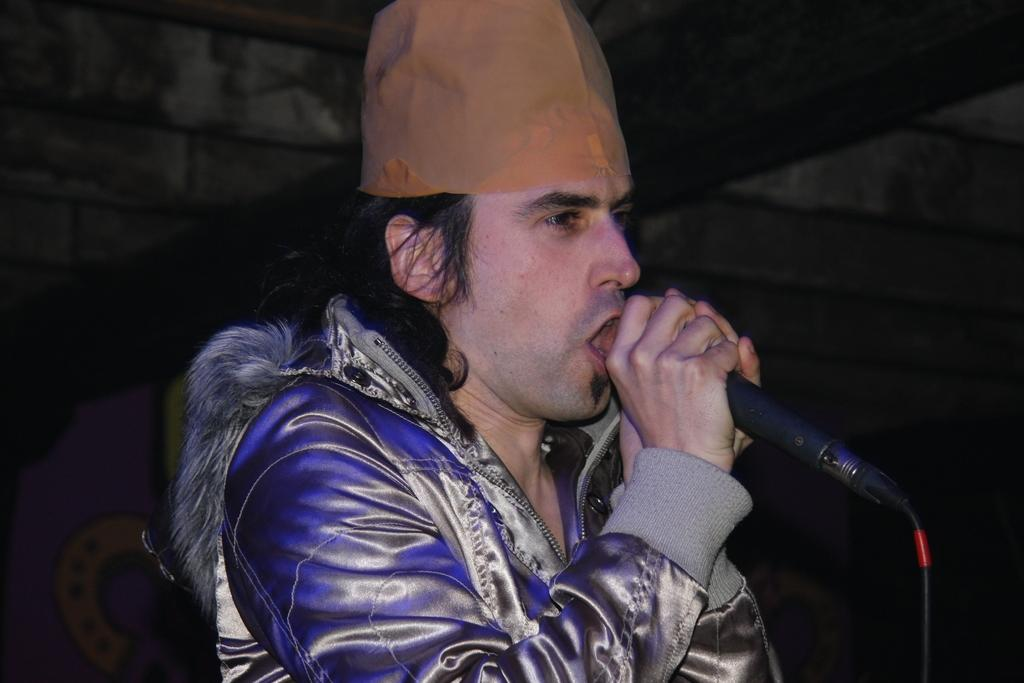What is the main subject of the image? There is a man in the image. What is the man doing in the image? The man is singing in the image. What object is the man holding while singing? The man is holding a microphone in the image. What type of clothing is the man wearing on his upper body? The man is wearing a coat in the image. What type of headwear is the man wearing? The man is wearing a cap in the image. What type of crime is being committed in the image? There is no crime being committed in the image; it features a man singing while holding a microphone. What type of cloth is being used to make the bed in the image? There is no bed present in the image, so it is not possible to determine the type of cloth being used for it. 